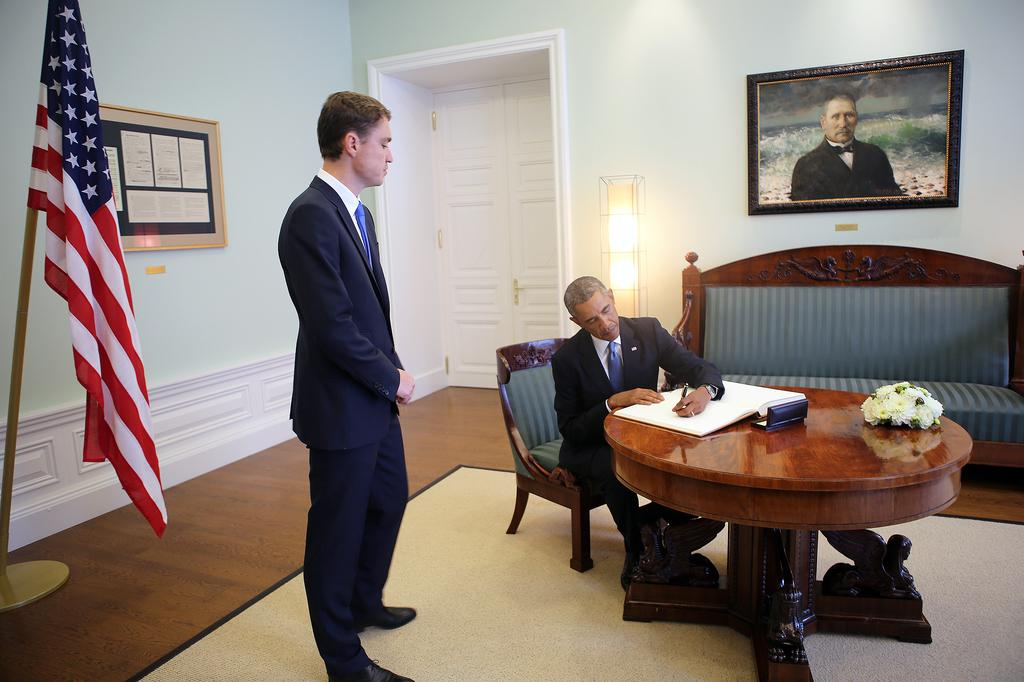Who is the main subject in the image? There is a man in the image. What is the man doing in the image? The man is staring at a person. Can you describe the person the man is staring at? The person is sitting on a sofa and is writing. What can be seen on the left side of the image? There is a flag on the left side of the image. What is located on the right side of the image? There is a door on the right side of the image. What type of fear can be seen on the goat's face in the image? There is no goat present in the image, so it is not possible to determine any fear on its face. 